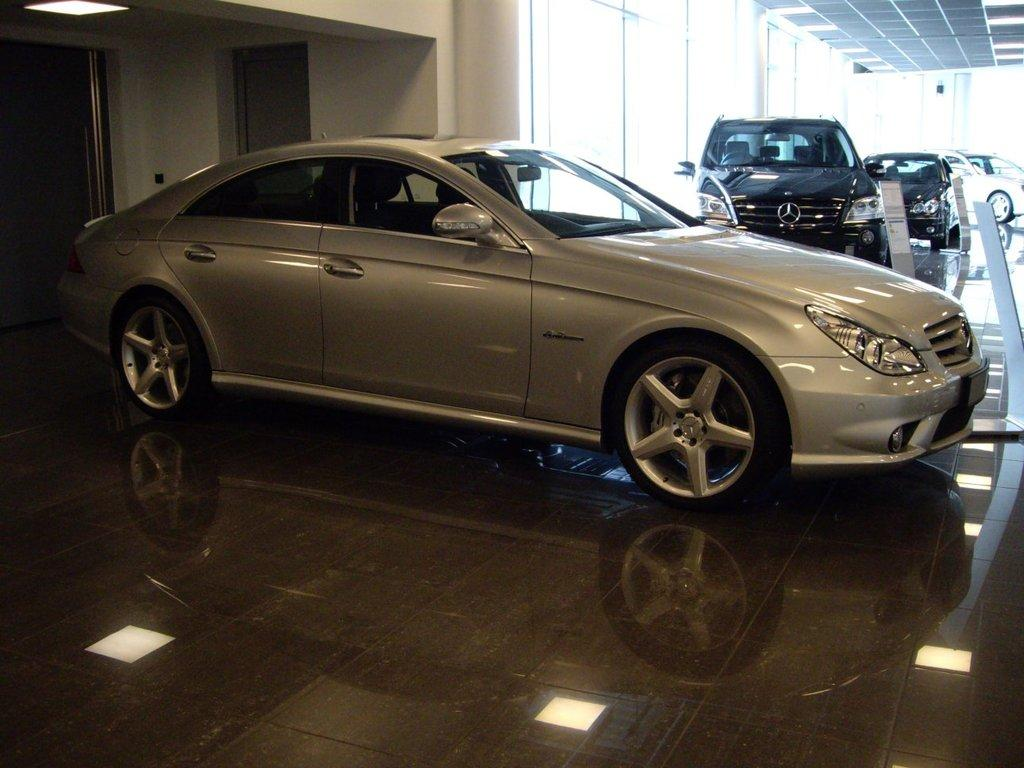What can be seen inside the building in the image? There are cars parked in the showroom. What type of doors can be seen in the image? There are glass doors in the image. What is visible on the interior side of the building? There is a wall visible in the image. Where can the ants be found in the image? There are no ants present in the image. What type of soup is being served in the showroom? There is no soup present in the image; it is a showroom for cars. 